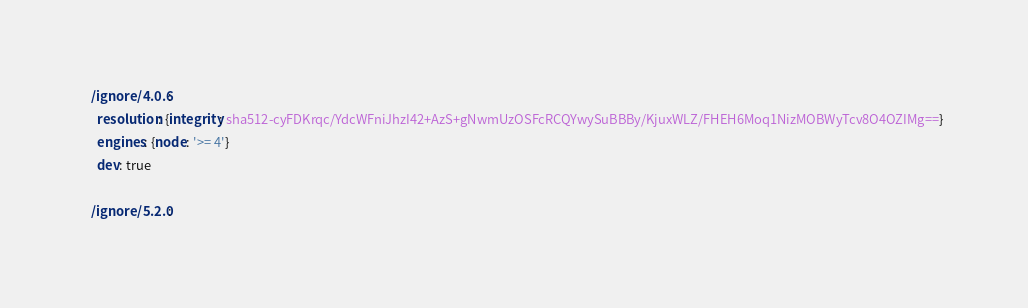Convert code to text. <code><loc_0><loc_0><loc_500><loc_500><_YAML_>
  /ignore/4.0.6:
    resolution: {integrity: sha512-cyFDKrqc/YdcWFniJhzI42+AzS+gNwmUzOSFcRCQYwySuBBBy/KjuxWLZ/FHEH6Moq1NizMOBWyTcv8O4OZIMg==}
    engines: {node: '>= 4'}
    dev: true

  /ignore/5.2.0:</code> 